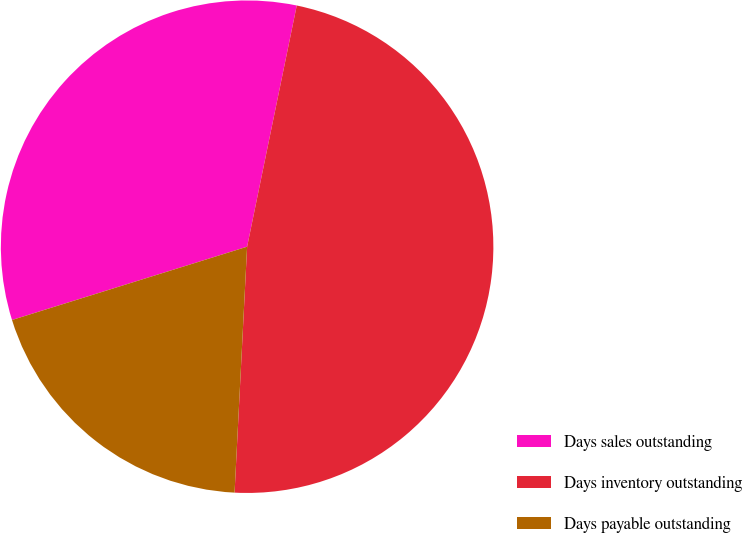Convert chart. <chart><loc_0><loc_0><loc_500><loc_500><pie_chart><fcel>Days sales outstanding<fcel>Days inventory outstanding<fcel>Days payable outstanding<nl><fcel>33.04%<fcel>47.58%<fcel>19.38%<nl></chart> 